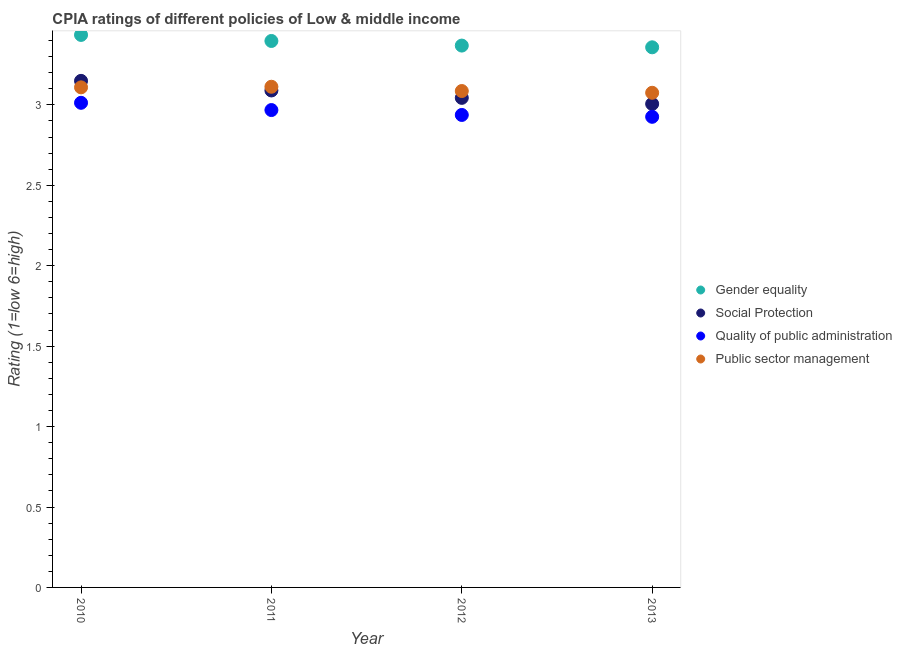What is the cpia rating of social protection in 2012?
Give a very brief answer. 3.04. Across all years, what is the maximum cpia rating of quality of public administration?
Keep it short and to the point. 3.01. Across all years, what is the minimum cpia rating of quality of public administration?
Your response must be concise. 2.93. In which year was the cpia rating of quality of public administration maximum?
Offer a terse response. 2010. In which year was the cpia rating of gender equality minimum?
Give a very brief answer. 2013. What is the total cpia rating of gender equality in the graph?
Ensure brevity in your answer.  13.56. What is the difference between the cpia rating of public sector management in 2010 and that in 2012?
Your answer should be compact. 0.02. What is the difference between the cpia rating of public sector management in 2010 and the cpia rating of gender equality in 2012?
Your response must be concise. -0.26. What is the average cpia rating of gender equality per year?
Your answer should be compact. 3.39. In the year 2010, what is the difference between the cpia rating of social protection and cpia rating of public sector management?
Your answer should be very brief. 0.04. What is the ratio of the cpia rating of social protection in 2010 to that in 2012?
Give a very brief answer. 1.03. What is the difference between the highest and the second highest cpia rating of quality of public administration?
Offer a very short reply. 0.05. What is the difference between the highest and the lowest cpia rating of gender equality?
Ensure brevity in your answer.  0.08. In how many years, is the cpia rating of social protection greater than the average cpia rating of social protection taken over all years?
Keep it short and to the point. 2. Is the sum of the cpia rating of gender equality in 2010 and 2013 greater than the maximum cpia rating of social protection across all years?
Your answer should be compact. Yes. Is it the case that in every year, the sum of the cpia rating of gender equality and cpia rating of social protection is greater than the cpia rating of quality of public administration?
Ensure brevity in your answer.  Yes. Is the cpia rating of gender equality strictly greater than the cpia rating of quality of public administration over the years?
Your response must be concise. Yes. Is the cpia rating of public sector management strictly less than the cpia rating of quality of public administration over the years?
Your response must be concise. No. How many dotlines are there?
Offer a terse response. 4. How many legend labels are there?
Your answer should be very brief. 4. What is the title of the graph?
Your answer should be very brief. CPIA ratings of different policies of Low & middle income. Does "Terrestrial protected areas" appear as one of the legend labels in the graph?
Offer a terse response. No. What is the label or title of the X-axis?
Offer a terse response. Year. What is the Rating (1=low 6=high) of Gender equality in 2010?
Provide a short and direct response. 3.44. What is the Rating (1=low 6=high) in Social Protection in 2010?
Keep it short and to the point. 3.15. What is the Rating (1=low 6=high) in Quality of public administration in 2010?
Your answer should be compact. 3.01. What is the Rating (1=low 6=high) of Public sector management in 2010?
Provide a succinct answer. 3.11. What is the Rating (1=low 6=high) of Gender equality in 2011?
Keep it short and to the point. 3.4. What is the Rating (1=low 6=high) in Social Protection in 2011?
Ensure brevity in your answer.  3.09. What is the Rating (1=low 6=high) of Quality of public administration in 2011?
Provide a succinct answer. 2.97. What is the Rating (1=low 6=high) of Public sector management in 2011?
Provide a succinct answer. 3.11. What is the Rating (1=low 6=high) in Gender equality in 2012?
Keep it short and to the point. 3.37. What is the Rating (1=low 6=high) of Social Protection in 2012?
Your answer should be compact. 3.04. What is the Rating (1=low 6=high) in Quality of public administration in 2012?
Your answer should be compact. 2.94. What is the Rating (1=low 6=high) of Public sector management in 2012?
Offer a terse response. 3.09. What is the Rating (1=low 6=high) in Gender equality in 2013?
Your answer should be compact. 3.36. What is the Rating (1=low 6=high) in Social Protection in 2013?
Your answer should be compact. 3.01. What is the Rating (1=low 6=high) in Quality of public administration in 2013?
Offer a terse response. 2.93. What is the Rating (1=low 6=high) in Public sector management in 2013?
Offer a terse response. 3.08. Across all years, what is the maximum Rating (1=low 6=high) in Gender equality?
Offer a very short reply. 3.44. Across all years, what is the maximum Rating (1=low 6=high) of Social Protection?
Give a very brief answer. 3.15. Across all years, what is the maximum Rating (1=low 6=high) in Quality of public administration?
Ensure brevity in your answer.  3.01. Across all years, what is the maximum Rating (1=low 6=high) of Public sector management?
Ensure brevity in your answer.  3.11. Across all years, what is the minimum Rating (1=low 6=high) of Gender equality?
Your response must be concise. 3.36. Across all years, what is the minimum Rating (1=low 6=high) of Social Protection?
Provide a succinct answer. 3.01. Across all years, what is the minimum Rating (1=low 6=high) of Quality of public administration?
Your response must be concise. 2.93. Across all years, what is the minimum Rating (1=low 6=high) of Public sector management?
Your response must be concise. 3.08. What is the total Rating (1=low 6=high) in Gender equality in the graph?
Provide a short and direct response. 13.56. What is the total Rating (1=low 6=high) of Social Protection in the graph?
Offer a very short reply. 12.29. What is the total Rating (1=low 6=high) in Quality of public administration in the graph?
Your answer should be compact. 11.84. What is the total Rating (1=low 6=high) of Public sector management in the graph?
Offer a very short reply. 12.38. What is the difference between the Rating (1=low 6=high) in Gender equality in 2010 and that in 2011?
Provide a short and direct response. 0.04. What is the difference between the Rating (1=low 6=high) of Social Protection in 2010 and that in 2011?
Keep it short and to the point. 0.06. What is the difference between the Rating (1=low 6=high) of Quality of public administration in 2010 and that in 2011?
Give a very brief answer. 0.04. What is the difference between the Rating (1=low 6=high) in Public sector management in 2010 and that in 2011?
Provide a succinct answer. -0. What is the difference between the Rating (1=low 6=high) of Gender equality in 2010 and that in 2012?
Your response must be concise. 0.07. What is the difference between the Rating (1=low 6=high) in Social Protection in 2010 and that in 2012?
Provide a short and direct response. 0.11. What is the difference between the Rating (1=low 6=high) in Quality of public administration in 2010 and that in 2012?
Keep it short and to the point. 0.08. What is the difference between the Rating (1=low 6=high) in Public sector management in 2010 and that in 2012?
Give a very brief answer. 0.02. What is the difference between the Rating (1=low 6=high) of Gender equality in 2010 and that in 2013?
Make the answer very short. 0.08. What is the difference between the Rating (1=low 6=high) in Social Protection in 2010 and that in 2013?
Provide a short and direct response. 0.14. What is the difference between the Rating (1=low 6=high) of Quality of public administration in 2010 and that in 2013?
Give a very brief answer. 0.09. What is the difference between the Rating (1=low 6=high) of Public sector management in 2010 and that in 2013?
Your answer should be compact. 0.03. What is the difference between the Rating (1=low 6=high) in Gender equality in 2011 and that in 2012?
Offer a terse response. 0.03. What is the difference between the Rating (1=low 6=high) in Social Protection in 2011 and that in 2012?
Your response must be concise. 0.05. What is the difference between the Rating (1=low 6=high) of Quality of public administration in 2011 and that in 2012?
Offer a terse response. 0.03. What is the difference between the Rating (1=low 6=high) in Public sector management in 2011 and that in 2012?
Give a very brief answer. 0.03. What is the difference between the Rating (1=low 6=high) of Gender equality in 2011 and that in 2013?
Your answer should be compact. 0.04. What is the difference between the Rating (1=low 6=high) in Social Protection in 2011 and that in 2013?
Your answer should be compact. 0.08. What is the difference between the Rating (1=low 6=high) of Quality of public administration in 2011 and that in 2013?
Make the answer very short. 0.04. What is the difference between the Rating (1=low 6=high) in Public sector management in 2011 and that in 2013?
Keep it short and to the point. 0.04. What is the difference between the Rating (1=low 6=high) in Gender equality in 2012 and that in 2013?
Provide a succinct answer. 0.01. What is the difference between the Rating (1=low 6=high) in Social Protection in 2012 and that in 2013?
Offer a very short reply. 0.04. What is the difference between the Rating (1=low 6=high) in Quality of public administration in 2012 and that in 2013?
Provide a short and direct response. 0.01. What is the difference between the Rating (1=low 6=high) of Public sector management in 2012 and that in 2013?
Keep it short and to the point. 0.01. What is the difference between the Rating (1=low 6=high) of Gender equality in 2010 and the Rating (1=low 6=high) of Social Protection in 2011?
Give a very brief answer. 0.35. What is the difference between the Rating (1=low 6=high) in Gender equality in 2010 and the Rating (1=low 6=high) in Quality of public administration in 2011?
Make the answer very short. 0.47. What is the difference between the Rating (1=low 6=high) in Gender equality in 2010 and the Rating (1=low 6=high) in Public sector management in 2011?
Your answer should be compact. 0.32. What is the difference between the Rating (1=low 6=high) in Social Protection in 2010 and the Rating (1=low 6=high) in Quality of public administration in 2011?
Keep it short and to the point. 0.18. What is the difference between the Rating (1=low 6=high) of Social Protection in 2010 and the Rating (1=low 6=high) of Public sector management in 2011?
Give a very brief answer. 0.04. What is the difference between the Rating (1=low 6=high) of Quality of public administration in 2010 and the Rating (1=low 6=high) of Public sector management in 2011?
Provide a short and direct response. -0.1. What is the difference between the Rating (1=low 6=high) in Gender equality in 2010 and the Rating (1=low 6=high) in Social Protection in 2012?
Your answer should be compact. 0.39. What is the difference between the Rating (1=low 6=high) in Gender equality in 2010 and the Rating (1=low 6=high) in Quality of public administration in 2012?
Offer a very short reply. 0.5. What is the difference between the Rating (1=low 6=high) of Gender equality in 2010 and the Rating (1=low 6=high) of Public sector management in 2012?
Your answer should be very brief. 0.35. What is the difference between the Rating (1=low 6=high) in Social Protection in 2010 and the Rating (1=low 6=high) in Quality of public administration in 2012?
Make the answer very short. 0.21. What is the difference between the Rating (1=low 6=high) in Social Protection in 2010 and the Rating (1=low 6=high) in Public sector management in 2012?
Keep it short and to the point. 0.06. What is the difference between the Rating (1=low 6=high) of Quality of public administration in 2010 and the Rating (1=low 6=high) of Public sector management in 2012?
Offer a terse response. -0.07. What is the difference between the Rating (1=low 6=high) of Gender equality in 2010 and the Rating (1=low 6=high) of Social Protection in 2013?
Your answer should be very brief. 0.43. What is the difference between the Rating (1=low 6=high) of Gender equality in 2010 and the Rating (1=low 6=high) of Quality of public administration in 2013?
Make the answer very short. 0.51. What is the difference between the Rating (1=low 6=high) of Gender equality in 2010 and the Rating (1=low 6=high) of Public sector management in 2013?
Provide a succinct answer. 0.36. What is the difference between the Rating (1=low 6=high) of Social Protection in 2010 and the Rating (1=low 6=high) of Quality of public administration in 2013?
Provide a short and direct response. 0.22. What is the difference between the Rating (1=low 6=high) of Social Protection in 2010 and the Rating (1=low 6=high) of Public sector management in 2013?
Offer a very short reply. 0.07. What is the difference between the Rating (1=low 6=high) of Quality of public administration in 2010 and the Rating (1=low 6=high) of Public sector management in 2013?
Provide a succinct answer. -0.06. What is the difference between the Rating (1=low 6=high) in Gender equality in 2011 and the Rating (1=low 6=high) in Social Protection in 2012?
Make the answer very short. 0.35. What is the difference between the Rating (1=low 6=high) of Gender equality in 2011 and the Rating (1=low 6=high) of Quality of public administration in 2012?
Provide a succinct answer. 0.46. What is the difference between the Rating (1=low 6=high) in Gender equality in 2011 and the Rating (1=low 6=high) in Public sector management in 2012?
Offer a very short reply. 0.31. What is the difference between the Rating (1=low 6=high) in Social Protection in 2011 and the Rating (1=low 6=high) in Quality of public administration in 2012?
Give a very brief answer. 0.15. What is the difference between the Rating (1=low 6=high) of Social Protection in 2011 and the Rating (1=low 6=high) of Public sector management in 2012?
Provide a short and direct response. 0. What is the difference between the Rating (1=low 6=high) of Quality of public administration in 2011 and the Rating (1=low 6=high) of Public sector management in 2012?
Make the answer very short. -0.12. What is the difference between the Rating (1=low 6=high) in Gender equality in 2011 and the Rating (1=low 6=high) in Social Protection in 2013?
Your response must be concise. 0.39. What is the difference between the Rating (1=low 6=high) in Gender equality in 2011 and the Rating (1=low 6=high) in Quality of public administration in 2013?
Your answer should be very brief. 0.47. What is the difference between the Rating (1=low 6=high) of Gender equality in 2011 and the Rating (1=low 6=high) of Public sector management in 2013?
Offer a very short reply. 0.32. What is the difference between the Rating (1=low 6=high) of Social Protection in 2011 and the Rating (1=low 6=high) of Quality of public administration in 2013?
Give a very brief answer. 0.16. What is the difference between the Rating (1=low 6=high) of Social Protection in 2011 and the Rating (1=low 6=high) of Public sector management in 2013?
Your answer should be compact. 0.01. What is the difference between the Rating (1=low 6=high) of Quality of public administration in 2011 and the Rating (1=low 6=high) of Public sector management in 2013?
Your answer should be compact. -0.11. What is the difference between the Rating (1=low 6=high) of Gender equality in 2012 and the Rating (1=low 6=high) of Social Protection in 2013?
Keep it short and to the point. 0.36. What is the difference between the Rating (1=low 6=high) in Gender equality in 2012 and the Rating (1=low 6=high) in Quality of public administration in 2013?
Your answer should be compact. 0.44. What is the difference between the Rating (1=low 6=high) of Gender equality in 2012 and the Rating (1=low 6=high) of Public sector management in 2013?
Provide a short and direct response. 0.29. What is the difference between the Rating (1=low 6=high) of Social Protection in 2012 and the Rating (1=low 6=high) of Quality of public administration in 2013?
Keep it short and to the point. 0.12. What is the difference between the Rating (1=low 6=high) of Social Protection in 2012 and the Rating (1=low 6=high) of Public sector management in 2013?
Offer a terse response. -0.03. What is the difference between the Rating (1=low 6=high) in Quality of public administration in 2012 and the Rating (1=low 6=high) in Public sector management in 2013?
Your answer should be compact. -0.14. What is the average Rating (1=low 6=high) of Gender equality per year?
Keep it short and to the point. 3.39. What is the average Rating (1=low 6=high) of Social Protection per year?
Keep it short and to the point. 3.07. What is the average Rating (1=low 6=high) in Quality of public administration per year?
Your answer should be compact. 2.96. What is the average Rating (1=low 6=high) in Public sector management per year?
Your answer should be compact. 3.1. In the year 2010, what is the difference between the Rating (1=low 6=high) in Gender equality and Rating (1=low 6=high) in Social Protection?
Offer a terse response. 0.29. In the year 2010, what is the difference between the Rating (1=low 6=high) in Gender equality and Rating (1=low 6=high) in Quality of public administration?
Offer a terse response. 0.42. In the year 2010, what is the difference between the Rating (1=low 6=high) of Gender equality and Rating (1=low 6=high) of Public sector management?
Your answer should be very brief. 0.33. In the year 2010, what is the difference between the Rating (1=low 6=high) in Social Protection and Rating (1=low 6=high) in Quality of public administration?
Offer a very short reply. 0.14. In the year 2010, what is the difference between the Rating (1=low 6=high) of Social Protection and Rating (1=low 6=high) of Public sector management?
Provide a short and direct response. 0.04. In the year 2010, what is the difference between the Rating (1=low 6=high) of Quality of public administration and Rating (1=low 6=high) of Public sector management?
Make the answer very short. -0.1. In the year 2011, what is the difference between the Rating (1=low 6=high) in Gender equality and Rating (1=low 6=high) in Social Protection?
Keep it short and to the point. 0.31. In the year 2011, what is the difference between the Rating (1=low 6=high) in Gender equality and Rating (1=low 6=high) in Quality of public administration?
Make the answer very short. 0.43. In the year 2011, what is the difference between the Rating (1=low 6=high) in Gender equality and Rating (1=low 6=high) in Public sector management?
Make the answer very short. 0.28. In the year 2011, what is the difference between the Rating (1=low 6=high) in Social Protection and Rating (1=low 6=high) in Quality of public administration?
Your response must be concise. 0.12. In the year 2011, what is the difference between the Rating (1=low 6=high) in Social Protection and Rating (1=low 6=high) in Public sector management?
Your answer should be compact. -0.02. In the year 2011, what is the difference between the Rating (1=low 6=high) in Quality of public administration and Rating (1=low 6=high) in Public sector management?
Keep it short and to the point. -0.14. In the year 2012, what is the difference between the Rating (1=low 6=high) in Gender equality and Rating (1=low 6=high) in Social Protection?
Offer a very short reply. 0.33. In the year 2012, what is the difference between the Rating (1=low 6=high) in Gender equality and Rating (1=low 6=high) in Quality of public administration?
Your answer should be compact. 0.43. In the year 2012, what is the difference between the Rating (1=low 6=high) in Gender equality and Rating (1=low 6=high) in Public sector management?
Give a very brief answer. 0.28. In the year 2012, what is the difference between the Rating (1=low 6=high) of Social Protection and Rating (1=low 6=high) of Quality of public administration?
Provide a succinct answer. 0.11. In the year 2012, what is the difference between the Rating (1=low 6=high) in Social Protection and Rating (1=low 6=high) in Public sector management?
Give a very brief answer. -0.04. In the year 2012, what is the difference between the Rating (1=low 6=high) in Quality of public administration and Rating (1=low 6=high) in Public sector management?
Provide a short and direct response. -0.15. In the year 2013, what is the difference between the Rating (1=low 6=high) of Gender equality and Rating (1=low 6=high) of Social Protection?
Offer a terse response. 0.35. In the year 2013, what is the difference between the Rating (1=low 6=high) of Gender equality and Rating (1=low 6=high) of Quality of public administration?
Ensure brevity in your answer.  0.43. In the year 2013, what is the difference between the Rating (1=low 6=high) of Gender equality and Rating (1=low 6=high) of Public sector management?
Provide a succinct answer. 0.28. In the year 2013, what is the difference between the Rating (1=low 6=high) of Social Protection and Rating (1=low 6=high) of Quality of public administration?
Provide a short and direct response. 0.08. In the year 2013, what is the difference between the Rating (1=low 6=high) of Social Protection and Rating (1=low 6=high) of Public sector management?
Offer a very short reply. -0.07. In the year 2013, what is the difference between the Rating (1=low 6=high) of Quality of public administration and Rating (1=low 6=high) of Public sector management?
Provide a succinct answer. -0.15. What is the ratio of the Rating (1=low 6=high) in Gender equality in 2010 to that in 2011?
Provide a short and direct response. 1.01. What is the ratio of the Rating (1=low 6=high) of Social Protection in 2010 to that in 2011?
Keep it short and to the point. 1.02. What is the ratio of the Rating (1=low 6=high) of Quality of public administration in 2010 to that in 2011?
Your answer should be very brief. 1.02. What is the ratio of the Rating (1=low 6=high) in Gender equality in 2010 to that in 2012?
Your answer should be compact. 1.02. What is the ratio of the Rating (1=low 6=high) of Social Protection in 2010 to that in 2012?
Offer a very short reply. 1.03. What is the ratio of the Rating (1=low 6=high) in Quality of public administration in 2010 to that in 2012?
Offer a terse response. 1.03. What is the ratio of the Rating (1=low 6=high) of Public sector management in 2010 to that in 2012?
Give a very brief answer. 1.01. What is the ratio of the Rating (1=low 6=high) in Gender equality in 2010 to that in 2013?
Ensure brevity in your answer.  1.02. What is the ratio of the Rating (1=low 6=high) in Social Protection in 2010 to that in 2013?
Your answer should be very brief. 1.05. What is the ratio of the Rating (1=low 6=high) in Quality of public administration in 2010 to that in 2013?
Give a very brief answer. 1.03. What is the ratio of the Rating (1=low 6=high) of Gender equality in 2011 to that in 2012?
Offer a terse response. 1.01. What is the ratio of the Rating (1=low 6=high) in Social Protection in 2011 to that in 2012?
Offer a very short reply. 1.02. What is the ratio of the Rating (1=low 6=high) in Quality of public administration in 2011 to that in 2012?
Make the answer very short. 1.01. What is the ratio of the Rating (1=low 6=high) in Public sector management in 2011 to that in 2012?
Provide a succinct answer. 1.01. What is the ratio of the Rating (1=low 6=high) in Gender equality in 2011 to that in 2013?
Your answer should be very brief. 1.01. What is the ratio of the Rating (1=low 6=high) in Social Protection in 2011 to that in 2013?
Your response must be concise. 1.03. What is the ratio of the Rating (1=low 6=high) of Quality of public administration in 2011 to that in 2013?
Provide a succinct answer. 1.01. What is the ratio of the Rating (1=low 6=high) in Public sector management in 2011 to that in 2013?
Provide a short and direct response. 1.01. What is the ratio of the Rating (1=low 6=high) of Social Protection in 2012 to that in 2013?
Keep it short and to the point. 1.01. What is the ratio of the Rating (1=low 6=high) of Quality of public administration in 2012 to that in 2013?
Provide a succinct answer. 1. What is the difference between the highest and the second highest Rating (1=low 6=high) of Gender equality?
Your answer should be compact. 0.04. What is the difference between the highest and the second highest Rating (1=low 6=high) in Social Protection?
Your answer should be very brief. 0.06. What is the difference between the highest and the second highest Rating (1=low 6=high) of Quality of public administration?
Your answer should be very brief. 0.04. What is the difference between the highest and the second highest Rating (1=low 6=high) of Public sector management?
Provide a short and direct response. 0. What is the difference between the highest and the lowest Rating (1=low 6=high) of Gender equality?
Your response must be concise. 0.08. What is the difference between the highest and the lowest Rating (1=low 6=high) of Social Protection?
Ensure brevity in your answer.  0.14. What is the difference between the highest and the lowest Rating (1=low 6=high) of Quality of public administration?
Provide a succinct answer. 0.09. What is the difference between the highest and the lowest Rating (1=low 6=high) in Public sector management?
Provide a short and direct response. 0.04. 